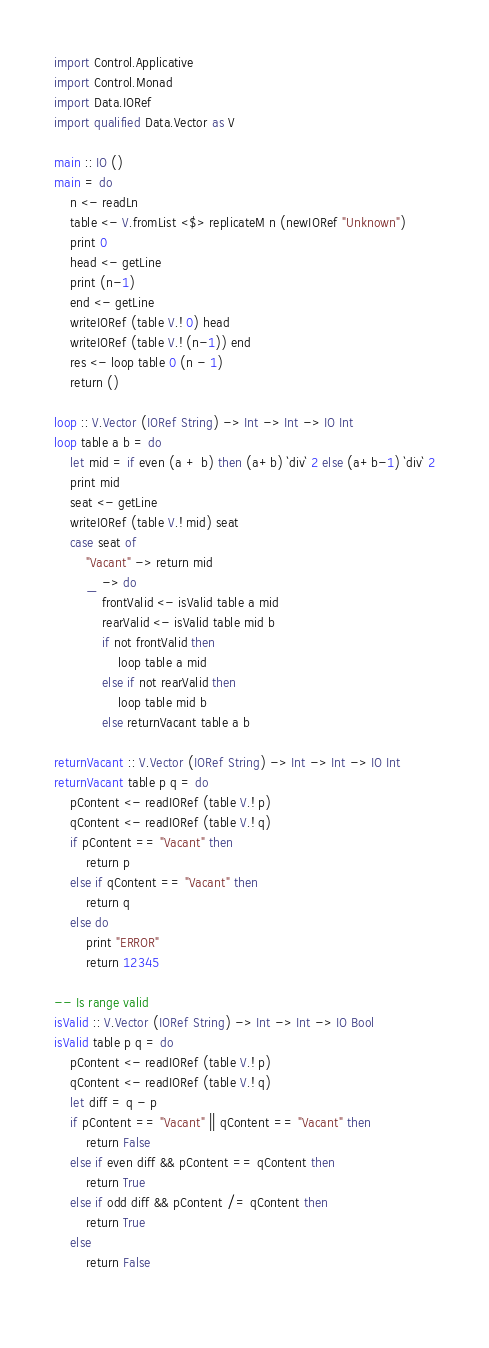<code> <loc_0><loc_0><loc_500><loc_500><_Haskell_>import Control.Applicative
import Control.Monad
import Data.IORef
import qualified Data.Vector as V

main :: IO ()
main = do
    n <- readLn
    table <- V.fromList <$> replicateM n (newIORef "Unknown")
    print 0
    head <- getLine
    print (n-1)
    end <- getLine
    writeIORef (table V.! 0) head
    writeIORef (table V.! (n-1)) end
    res <- loop table 0 (n - 1)
    return ()

loop :: V.Vector (IORef String) -> Int -> Int -> IO Int
loop table a b = do
    let mid = if even (a + b) then (a+b) `div` 2 else (a+b-1) `div` 2
    print mid
    seat <- getLine
    writeIORef (table V.! mid) seat
    case seat of
        "Vacant" -> return mid
        _ -> do
            frontValid <- isValid table a mid
            rearValid <- isValid table mid b
            if not frontValid then
                loop table a mid
            else if not rearValid then
                loop table mid b
            else returnVacant table a b

returnVacant :: V.Vector (IORef String) -> Int -> Int -> IO Int
returnVacant table p q = do
    pContent <- readIORef (table V.! p)
    qContent <- readIORef (table V.! q)
    if pContent == "Vacant" then
        return p
    else if qContent == "Vacant" then
        return q
    else do
        print "ERROR"
        return 12345

-- Is range valid
isValid :: V.Vector (IORef String) -> Int -> Int -> IO Bool
isValid table p q = do
    pContent <- readIORef (table V.! p)
    qContent <- readIORef (table V.! q)
    let diff = q - p
    if pContent == "Vacant" || qContent == "Vacant" then
        return False
    else if even diff && pContent == qContent then
        return True
    else if odd diff && pContent /= qContent then
        return True
    else
        return False
    
</code> 